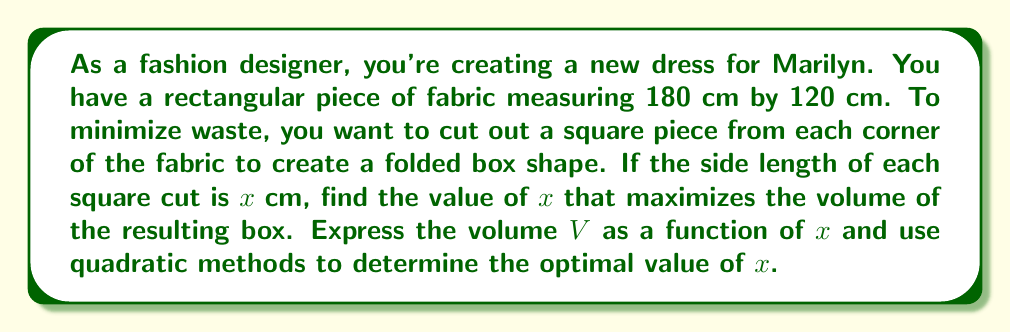Show me your answer to this math problem. 1) First, let's express the volume of the box in terms of $x$:
   Length of the box: $180 - 2x$
   Width of the box: $120 - 2x$
   Height of the box: $x$

   Volume: $V(x) = (180 - 2x)(120 - 2x)x$

2) Expand the equation:
   $V(x) = (21600 - 600x + 4x^2)x$
   $V(x) = 21600x - 600x^2 + 4x^3$

3) To find the maximum volume, we need to find the derivative and set it to zero:
   $\frac{dV}{dx} = 21600 - 1200x + 12x^2$

4) Set the derivative to zero:
   $21600 - 1200x + 12x^2 = 0$

5) Divide everything by 12:
   $1800 - 100x + x^2 = 0$

6) This is a quadratic equation. We can solve it using the quadratic formula:
   $x = \frac{-b \pm \sqrt{b^2 - 4ac}}{2a}$

   Where $a = 1$, $b = -100$, and $c = 1800$

7) Plugging in these values:
   $x = \frac{100 \pm \sqrt{10000 - 7200}}{2} = \frac{100 \pm \sqrt{2800}}{2}$

8) Simplify:
   $x = \frac{100 \pm 20\sqrt{7}}{2} = 50 \pm 10\sqrt{7}$

9) We need the positive solution (as length cannot be negative):
   $x = 50 + 10\sqrt{7} \approx 76.46$ cm

Therefore, to maximize the volume, each square cut should have a side length of approximately 76.46 cm.
Answer: $x = 50 + 10\sqrt{7}$ cm 